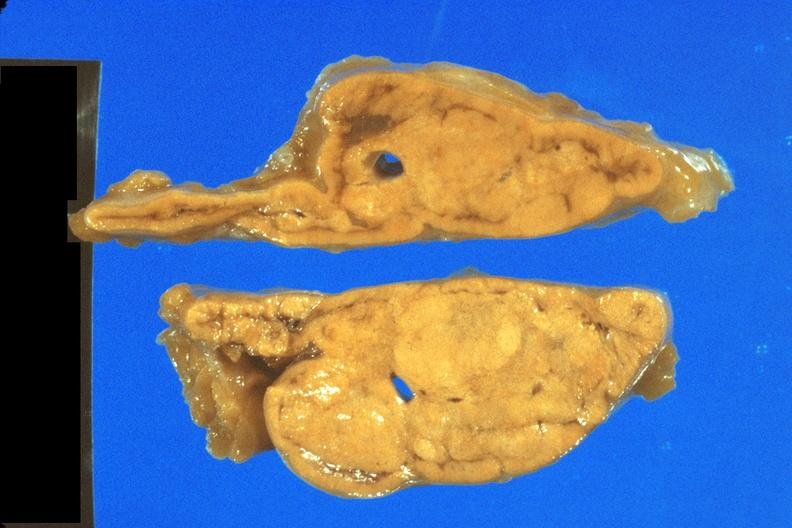s adrenal present?
Answer the question using a single word or phrase. Yes 